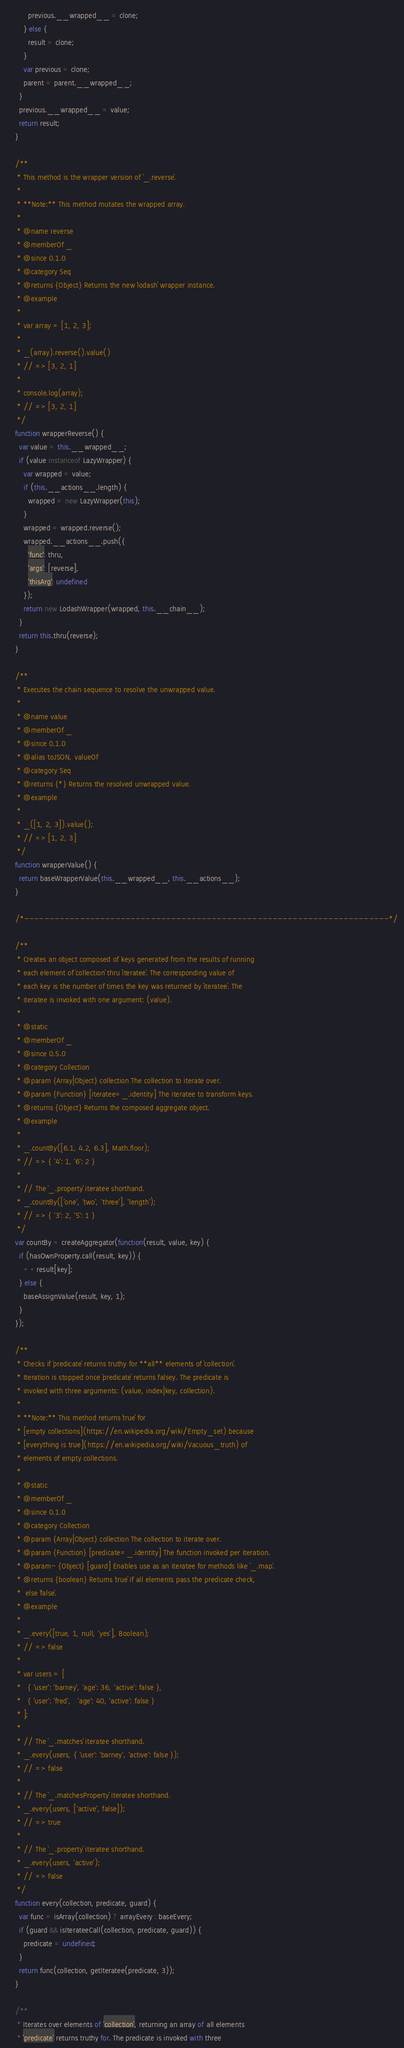<code> <loc_0><loc_0><loc_500><loc_500><_JavaScript_>          previous.__wrapped__ = clone;
        } else {
          result = clone;
        }
        var previous = clone;
        parent = parent.__wrapped__;
      }
      previous.__wrapped__ = value;
      return result;
    }

    /**
     * This method is the wrapper version of `_.reverse`.
     *
     * **Note:** This method mutates the wrapped array.
     *
     * @name reverse
     * @memberOf _
     * @since 0.1.0
     * @category Seq
     * @returns {Object} Returns the new `lodash` wrapper instance.
     * @example
     *
     * var array = [1, 2, 3];
     *
     * _(array).reverse().value()
     * // => [3, 2, 1]
     *
     * console.log(array);
     * // => [3, 2, 1]
     */
    function wrapperReverse() {
      var value = this.__wrapped__;
      if (value instanceof LazyWrapper) {
        var wrapped = value;
        if (this.__actions__.length) {
          wrapped = new LazyWrapper(this);
        }
        wrapped = wrapped.reverse();
        wrapped.__actions__.push({
          'func': thru,
          'args': [reverse],
          'thisArg': undefined
        });
        return new LodashWrapper(wrapped, this.__chain__);
      }
      return this.thru(reverse);
    }

    /**
     * Executes the chain sequence to resolve the unwrapped value.
     *
     * @name value
     * @memberOf _
     * @since 0.1.0
     * @alias toJSON, valueOf
     * @category Seq
     * @returns {*} Returns the resolved unwrapped value.
     * @example
     *
     * _([1, 2, 3]).value();
     * // => [1, 2, 3]
     */
    function wrapperValue() {
      return baseWrapperValue(this.__wrapped__, this.__actions__);
    }

    /*------------------------------------------------------------------------*/

    /**
     * Creates an object composed of keys generated from the results of running
     * each element of `collection` thru `iteratee`. The corresponding value of
     * each key is the number of times the key was returned by `iteratee`. The
     * iteratee is invoked with one argument: (value).
     *
     * @static
     * @memberOf _
     * @since 0.5.0
     * @category Collection
     * @param {Array|Object} collection The collection to iterate over.
     * @param {Function} [iteratee=_.identity] The iteratee to transform keys.
     * @returns {Object} Returns the composed aggregate object.
     * @example
     *
     * _.countBy([6.1, 4.2, 6.3], Math.floor);
     * // => { '4': 1, '6': 2 }
     *
     * // The `_.property` iteratee shorthand.
     * _.countBy(['one', 'two', 'three'], 'length');
     * // => { '3': 2, '5': 1 }
     */
    var countBy = createAggregator(function(result, value, key) {
      if (hasOwnProperty.call(result, key)) {
        ++result[key];
      } else {
        baseAssignValue(result, key, 1);
      }
    });

    /**
     * Checks if `predicate` returns truthy for **all** elements of `collection`.
     * Iteration is stopped once `predicate` returns falsey. The predicate is
     * invoked with three arguments: (value, index|key, collection).
     *
     * **Note:** This method returns `true` for
     * [empty collections](https://en.wikipedia.org/wiki/Empty_set) because
     * [everything is true](https://en.wikipedia.org/wiki/Vacuous_truth) of
     * elements of empty collections.
     *
     * @static
     * @memberOf _
     * @since 0.1.0
     * @category Collection
     * @param {Array|Object} collection The collection to iterate over.
     * @param {Function} [predicate=_.identity] The function invoked per iteration.
     * @param- {Object} [guard] Enables use as an iteratee for methods like `_.map`.
     * @returns {boolean} Returns `true` if all elements pass the predicate check,
     *  else `false`.
     * @example
     *
     * _.every([true, 1, null, 'yes'], Boolean);
     * // => false
     *
     * var users = [
     *   { 'user': 'barney', 'age': 36, 'active': false },
     *   { 'user': 'fred',   'age': 40, 'active': false }
     * ];
     *
     * // The `_.matches` iteratee shorthand.
     * _.every(users, { 'user': 'barney', 'active': false });
     * // => false
     *
     * // The `_.matchesProperty` iteratee shorthand.
     * _.every(users, ['active', false]);
     * // => true
     *
     * // The `_.property` iteratee shorthand.
     * _.every(users, 'active');
     * // => false
     */
    function every(collection, predicate, guard) {
      var func = isArray(collection) ? arrayEvery : baseEvery;
      if (guard && isIterateeCall(collection, predicate, guard)) {
        predicate = undefined;
      }
      return func(collection, getIteratee(predicate, 3));
    }

    /**
     * Iterates over elements of `collection`, returning an array of all elements
     * `predicate` returns truthy for. The predicate is invoked with three</code> 